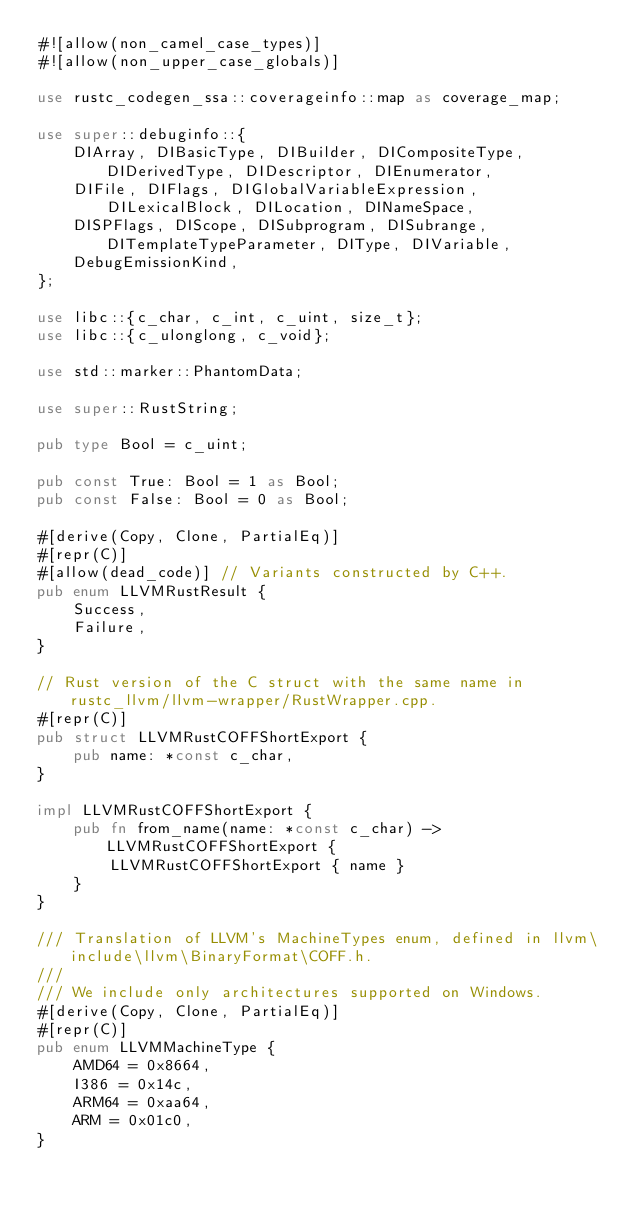Convert code to text. <code><loc_0><loc_0><loc_500><loc_500><_Rust_>#![allow(non_camel_case_types)]
#![allow(non_upper_case_globals)]

use rustc_codegen_ssa::coverageinfo::map as coverage_map;

use super::debuginfo::{
    DIArray, DIBasicType, DIBuilder, DICompositeType, DIDerivedType, DIDescriptor, DIEnumerator,
    DIFile, DIFlags, DIGlobalVariableExpression, DILexicalBlock, DILocation, DINameSpace,
    DISPFlags, DIScope, DISubprogram, DISubrange, DITemplateTypeParameter, DIType, DIVariable,
    DebugEmissionKind,
};

use libc::{c_char, c_int, c_uint, size_t};
use libc::{c_ulonglong, c_void};

use std::marker::PhantomData;

use super::RustString;

pub type Bool = c_uint;

pub const True: Bool = 1 as Bool;
pub const False: Bool = 0 as Bool;

#[derive(Copy, Clone, PartialEq)]
#[repr(C)]
#[allow(dead_code)] // Variants constructed by C++.
pub enum LLVMRustResult {
    Success,
    Failure,
}

// Rust version of the C struct with the same name in rustc_llvm/llvm-wrapper/RustWrapper.cpp.
#[repr(C)]
pub struct LLVMRustCOFFShortExport {
    pub name: *const c_char,
}

impl LLVMRustCOFFShortExport {
    pub fn from_name(name: *const c_char) -> LLVMRustCOFFShortExport {
        LLVMRustCOFFShortExport { name }
    }
}

/// Translation of LLVM's MachineTypes enum, defined in llvm\include\llvm\BinaryFormat\COFF.h.
///
/// We include only architectures supported on Windows.
#[derive(Copy, Clone, PartialEq)]
#[repr(C)]
pub enum LLVMMachineType {
    AMD64 = 0x8664,
    I386 = 0x14c,
    ARM64 = 0xaa64,
    ARM = 0x01c0,
}
</code> 